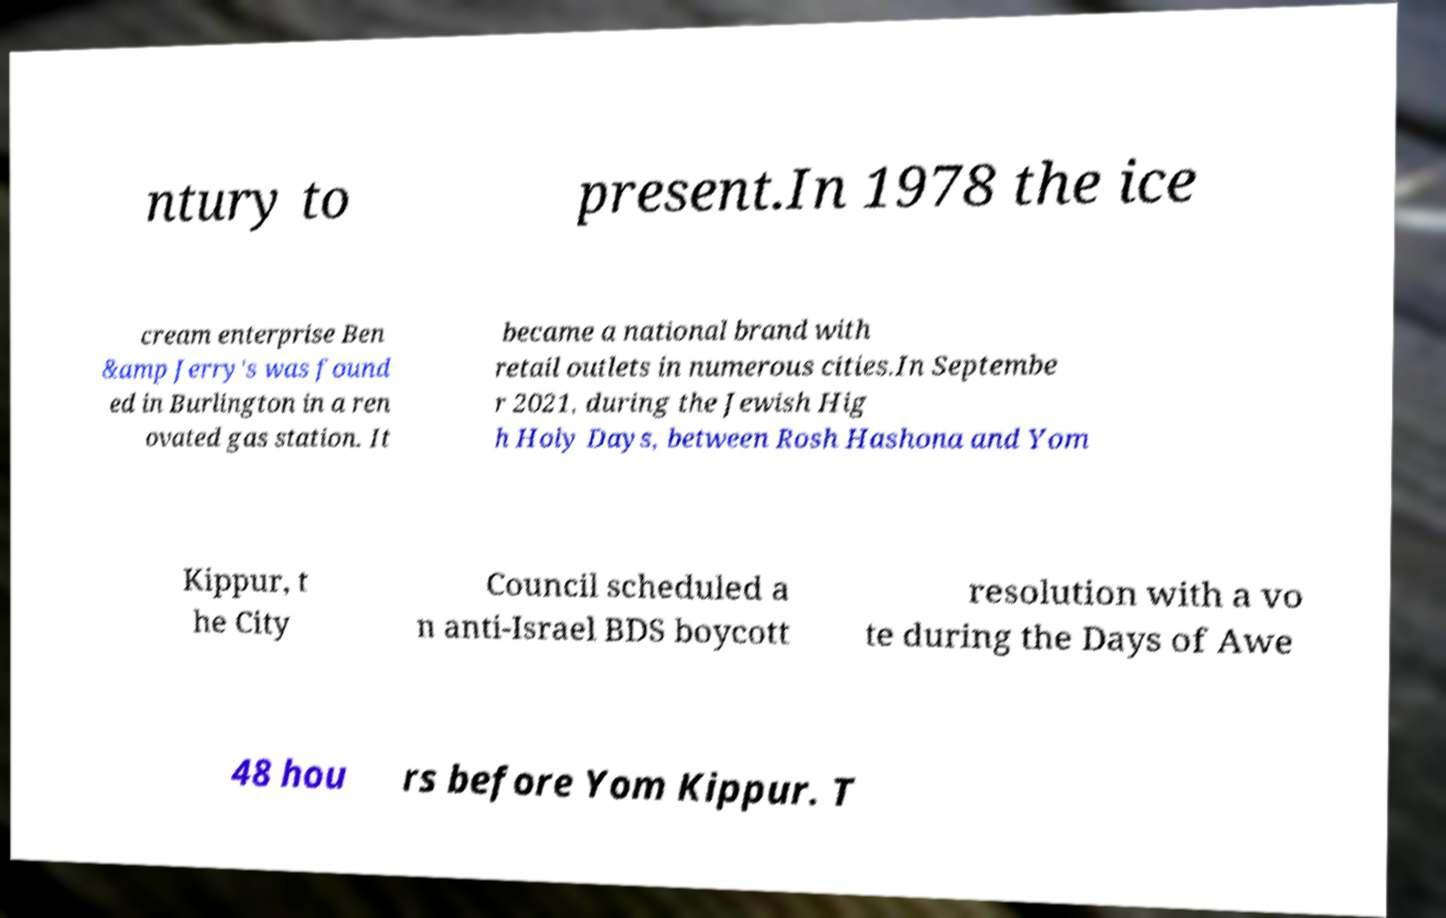Can you read and provide the text displayed in the image?This photo seems to have some interesting text. Can you extract and type it out for me? ntury to present.In 1978 the ice cream enterprise Ben &amp Jerry's was found ed in Burlington in a ren ovated gas station. It became a national brand with retail outlets in numerous cities.In Septembe r 2021, during the Jewish Hig h Holy Days, between Rosh Hashona and Yom Kippur, t he City Council scheduled a n anti-Israel BDS boycott resolution with a vo te during the Days of Awe 48 hou rs before Yom Kippur. T 